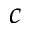<formula> <loc_0><loc_0><loc_500><loc_500>c</formula> 